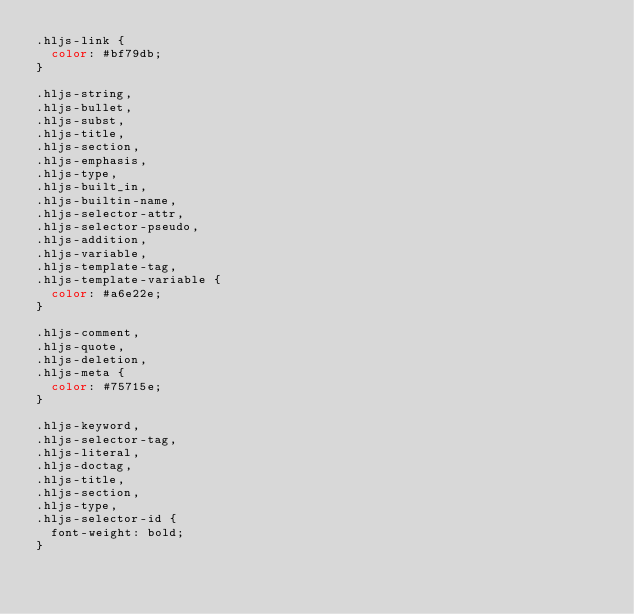<code> <loc_0><loc_0><loc_500><loc_500><_CSS_>.hljs-link {
  color: #bf79db;
}

.hljs-string,
.hljs-bullet,
.hljs-subst,
.hljs-title,
.hljs-section,
.hljs-emphasis,
.hljs-type,
.hljs-built_in,
.hljs-builtin-name,
.hljs-selector-attr,
.hljs-selector-pseudo,
.hljs-addition,
.hljs-variable,
.hljs-template-tag,
.hljs-template-variable {
  color: #a6e22e;
}

.hljs-comment,
.hljs-quote,
.hljs-deletion,
.hljs-meta {
  color: #75715e;
}

.hljs-keyword,
.hljs-selector-tag,
.hljs-literal,
.hljs-doctag,
.hljs-title,
.hljs-section,
.hljs-type,
.hljs-selector-id {
  font-weight: bold;
}
</code> 